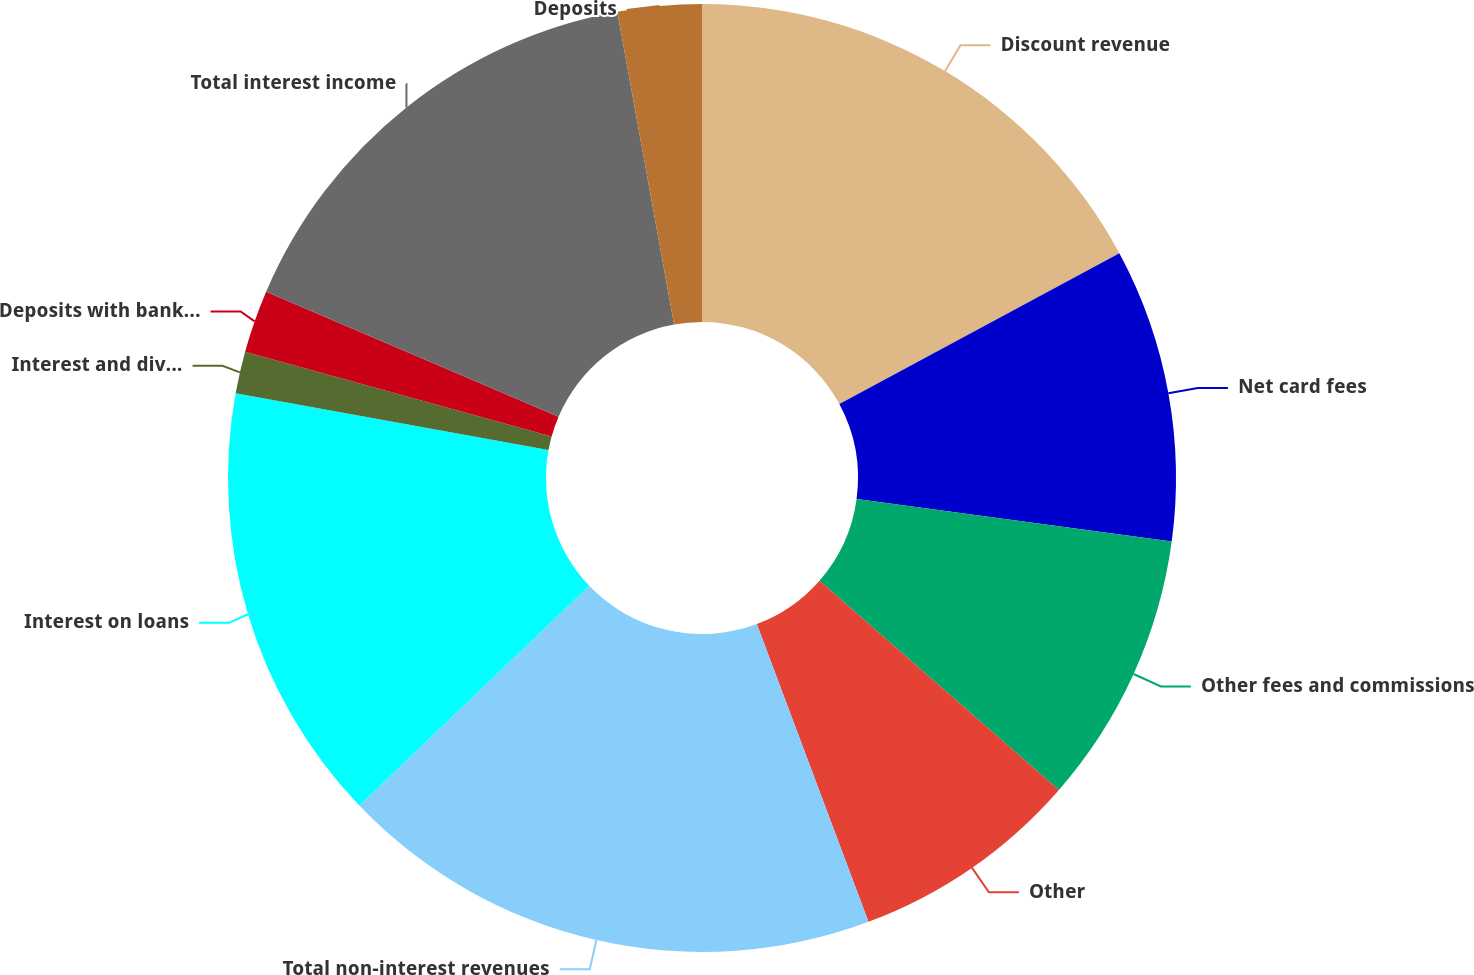<chart> <loc_0><loc_0><loc_500><loc_500><pie_chart><fcel>Discount revenue<fcel>Net card fees<fcel>Other fees and commissions<fcel>Other<fcel>Total non-interest revenues<fcel>Interest on loans<fcel>Interest and dividends on<fcel>Deposits with banks and other<fcel>Total interest income<fcel>Deposits<nl><fcel>17.14%<fcel>10.0%<fcel>9.29%<fcel>7.86%<fcel>18.57%<fcel>15.0%<fcel>1.43%<fcel>2.14%<fcel>15.71%<fcel>2.86%<nl></chart> 